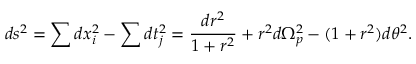<formula> <loc_0><loc_0><loc_500><loc_500>d s ^ { 2 } = \sum d x _ { i } ^ { 2 } - \sum d t _ { j } ^ { 2 } = \frac { d r ^ { 2 } } { 1 + r ^ { 2 } } + r ^ { 2 } d \Omega _ { p } ^ { 2 } - ( 1 + r ^ { 2 } ) d \theta ^ { 2 } .</formula> 